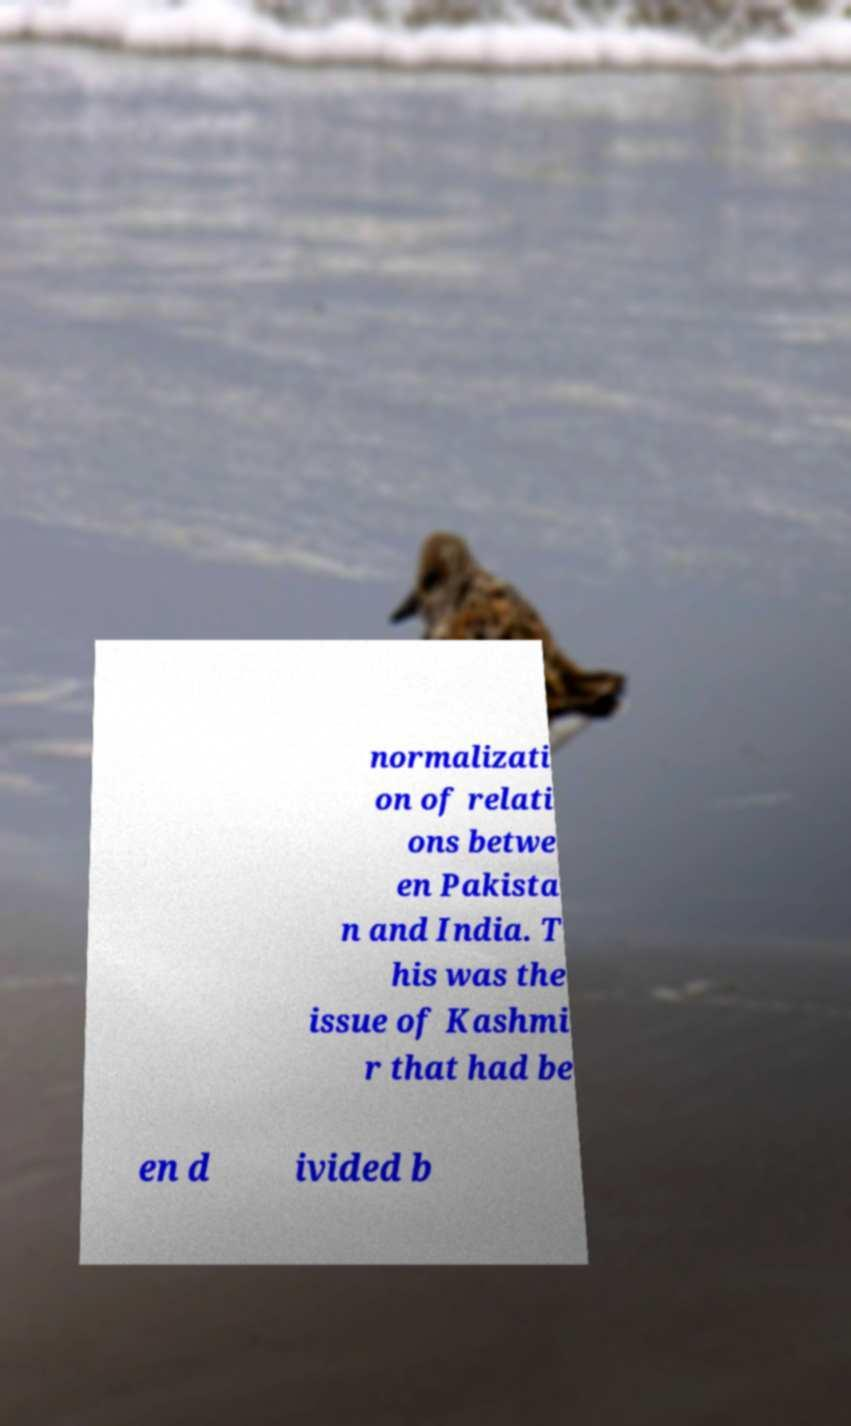Can you accurately transcribe the text from the provided image for me? normalizati on of relati ons betwe en Pakista n and India. T his was the issue of Kashmi r that had be en d ivided b 